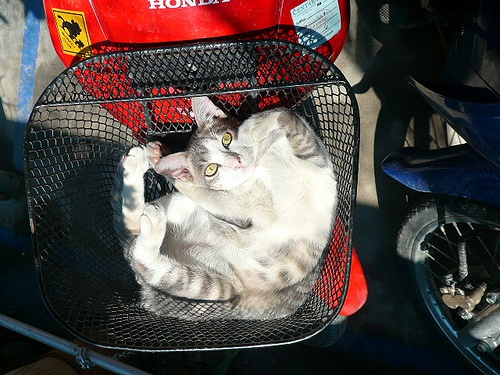Describe the objects in this image and their specific colors. I can see cat in darkgray, ivory, black, and gray tones, motorcycle in darkgray, black, gray, and navy tones, and motorcycle in darkgray, black, and gray tones in this image. 